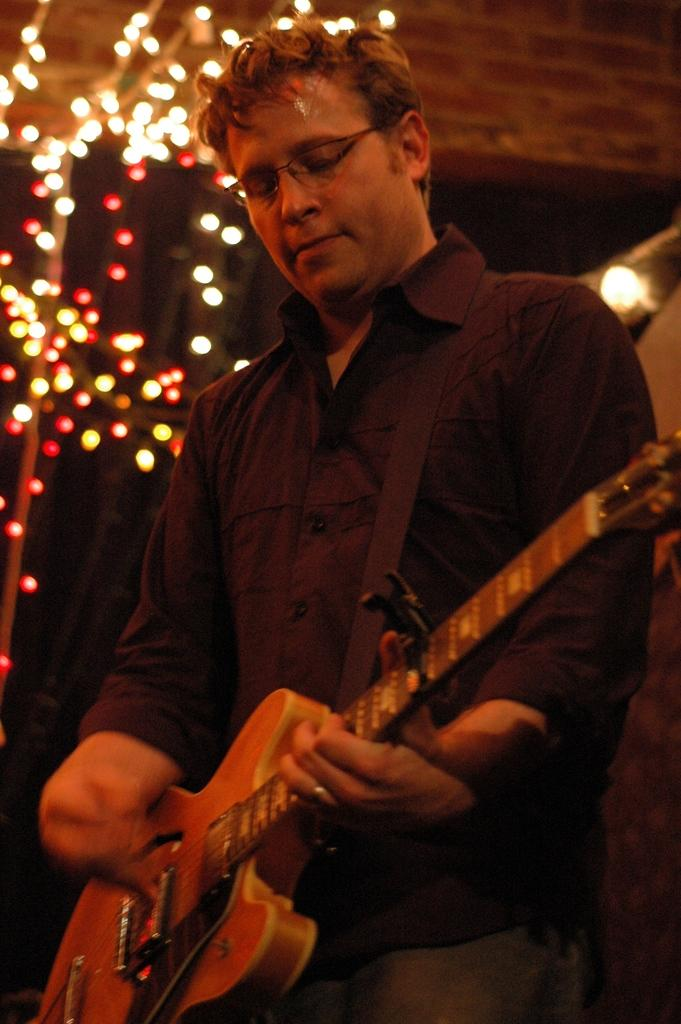What is the person in the image doing? The person is playing a guitar. Can you describe the background of the image? There are small lights visible in the background of the image. What type of wound can be seen on the pig in the image? There is no pig present in the image, and therefore no wound can be observed. 